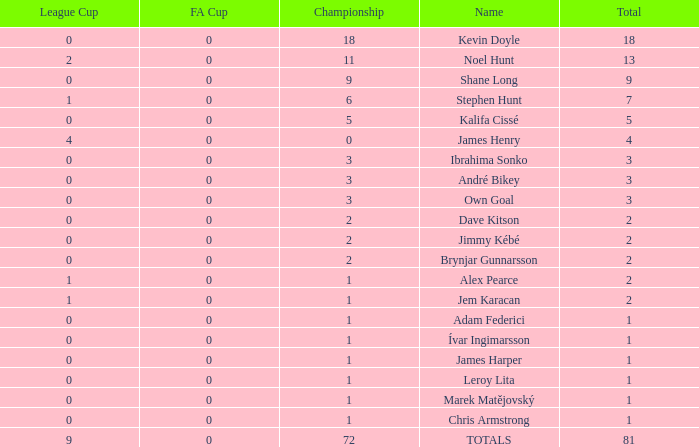What is the championship of Jem Karacan that has a total of 2 and a league cup more than 0? 1.0. 